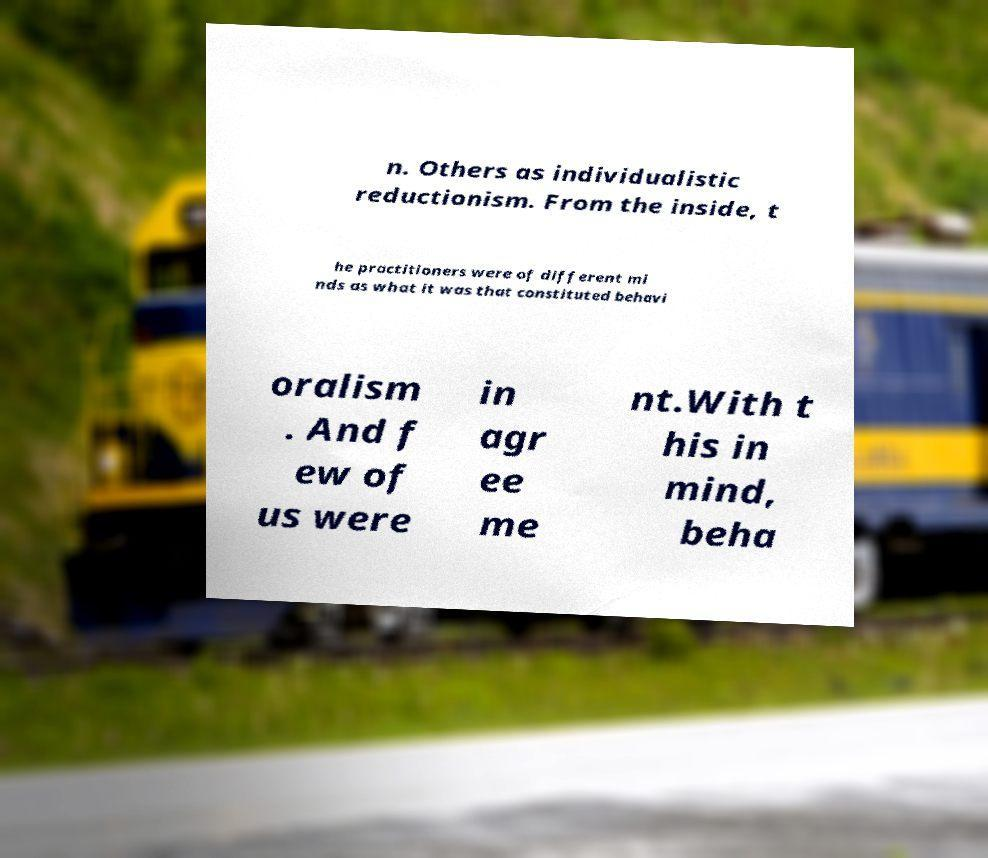For documentation purposes, I need the text within this image transcribed. Could you provide that? n. Others as individualistic reductionism. From the inside, t he practitioners were of different mi nds as what it was that constituted behavi oralism . And f ew of us were in agr ee me nt.With t his in mind, beha 